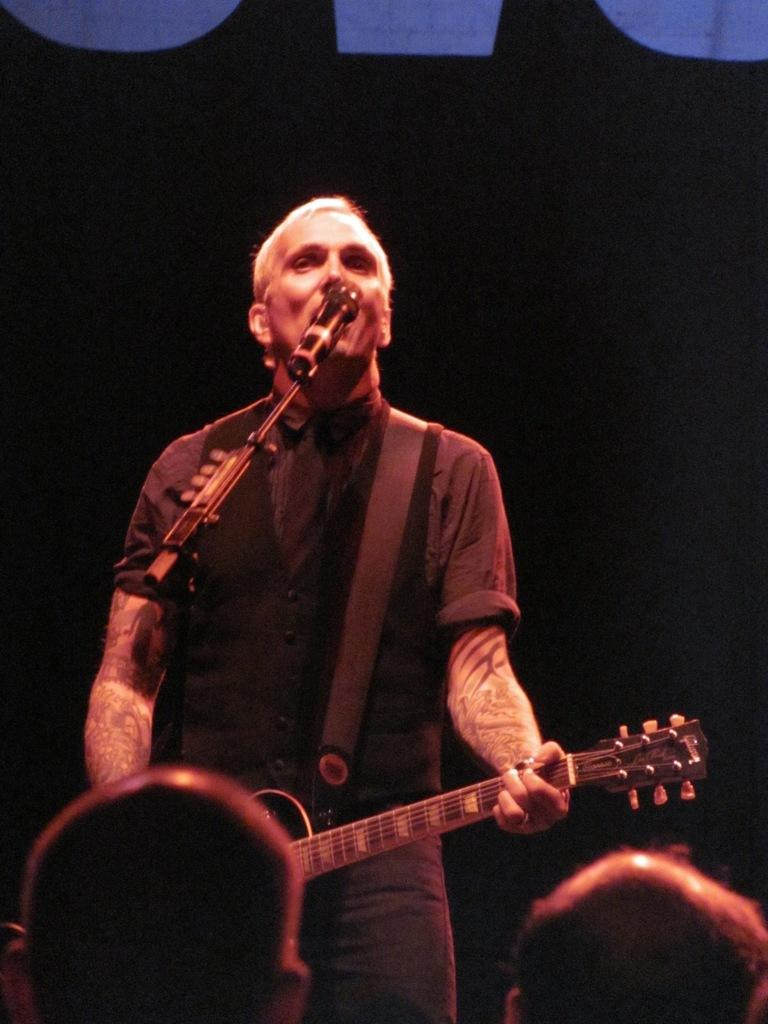What is the man in the image doing? The man is playing the guitar and singing. What object is in front of the man? There is a microphone in front of the man. Who is present in front of the man? There is a crowd in front of the man. What type of ball is being juggled by the rat in the image? There is no rat or ball present in the image. 